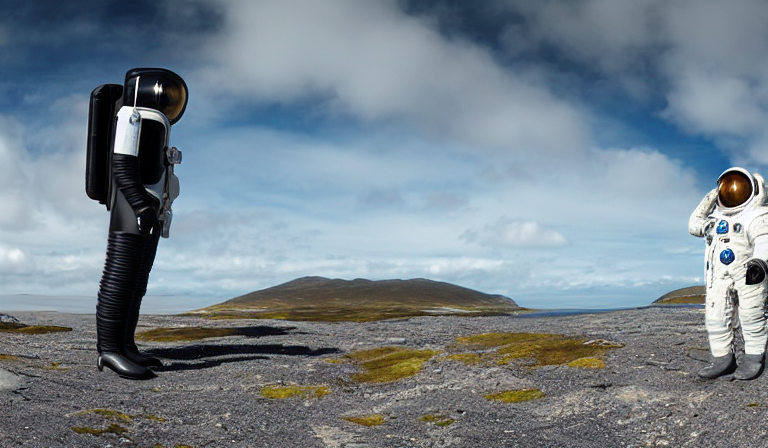Can you describe any allusions this image might draw to real-life space exploration? Certainly, the traditional astronaut figure alludes to the human endeavor to reach beyond our planet, exploring unfamiliar terrains much like the astronauts during the Apollo missions to the Moon. The landscape, though it is probably Earth, is reminiscent of lunar or Martian surfaces typically seen in space exploration imagery, evoking a sense of adventure and discovery while blurring the line between reality and imagination. 